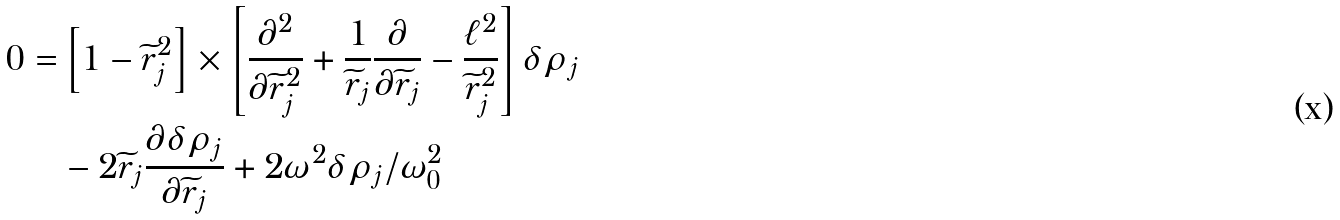<formula> <loc_0><loc_0><loc_500><loc_500>0 = & \left [ 1 - \widetilde { r } _ { j } ^ { 2 } \right ] \times \left [ \frac { \partial ^ { 2 } } { \partial \widetilde { r } ^ { 2 } _ { j } } + \frac { 1 } { \widetilde { r } _ { j } } \frac { \partial } { \partial \widetilde { r } _ { j } } - \frac { \ell ^ { 2 } } { \widetilde { r } _ { j } ^ { 2 } } \right ] \delta \rho _ { j } \\ & - 2 \widetilde { r } _ { j } \frac { \partial \delta \rho _ { j } } { \partial \widetilde { r } _ { j } } + 2 \omega ^ { 2 } \delta \rho _ { j } / \omega _ { 0 } ^ { 2 }</formula> 